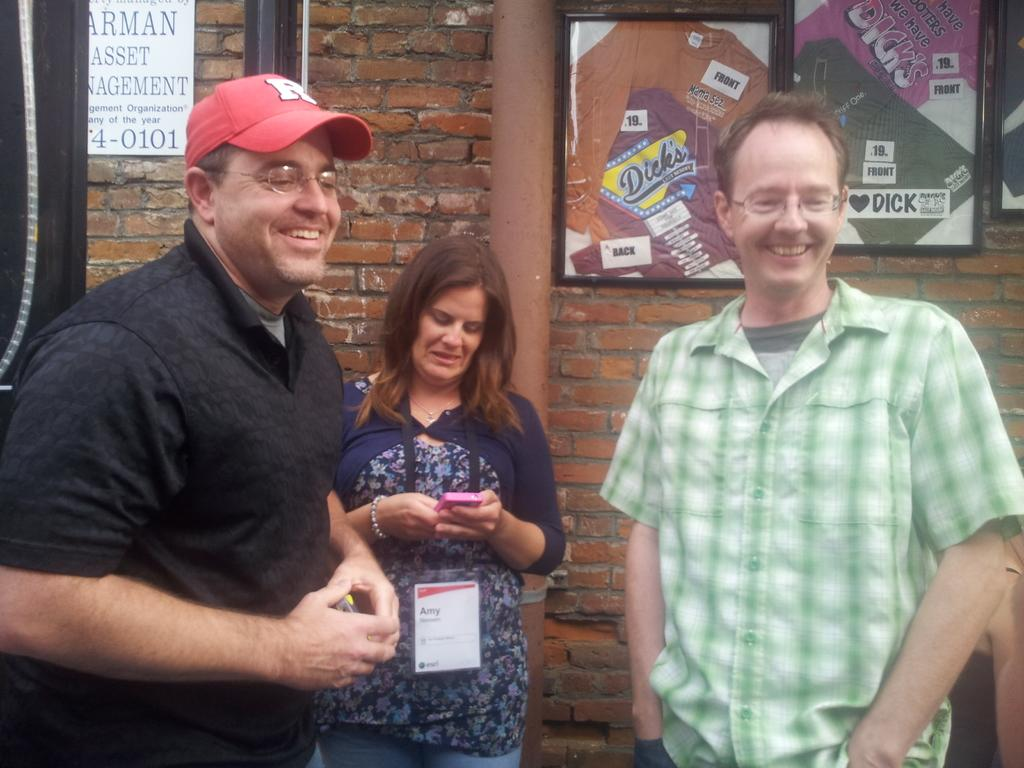How many people are in the image? There are three persons in the image. What are the persons doing in the image? The persons are standing and smiling. What can be seen in the background of the image? There is a wall in the background of the image. What is on the wall in the image? There are photo frames on the wall. Can you tell me how many times the person in the middle kicked the ball in the image? There is no ball present in the image, so it is not possible to determine how many times the person in the middle kicked it. 